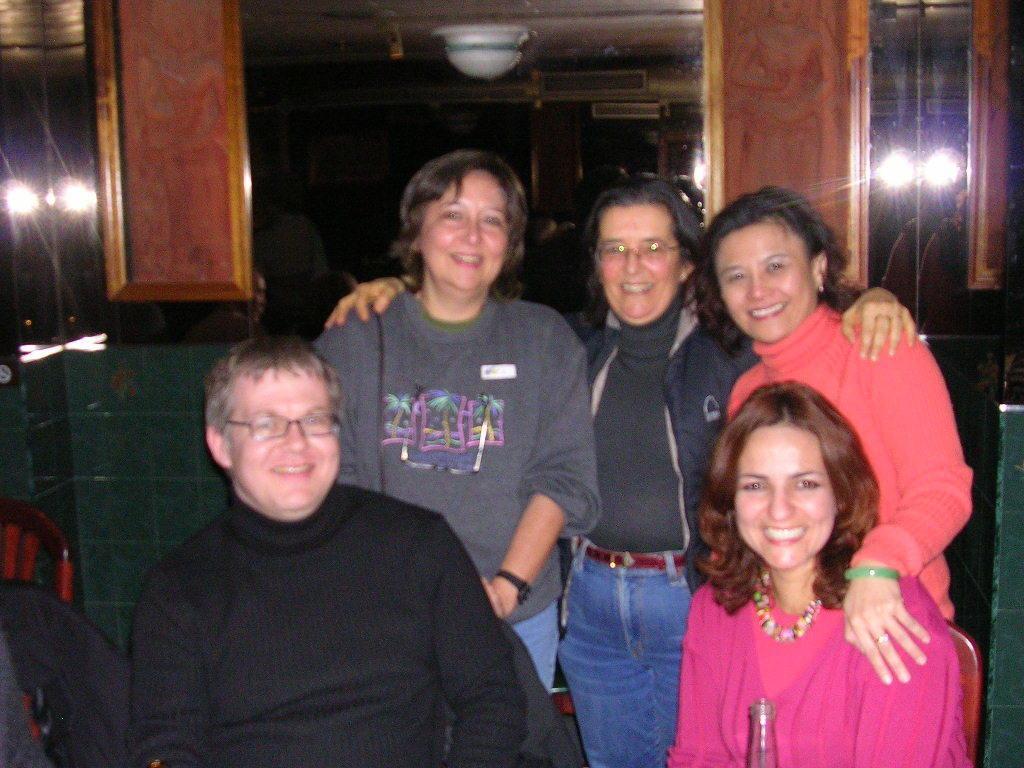Could you give a brief overview of what you see in this image? This is the picture of a room. In this image there are three persons standing and smiling. There are two persons sitting and smiling and there is a bottle in the foreground. At the back there is a chair and there are lights. 